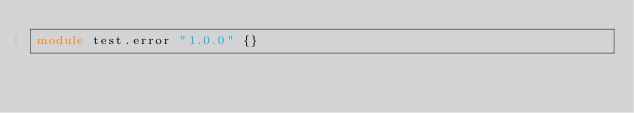Convert code to text. <code><loc_0><loc_0><loc_500><loc_500><_Ceylon_>module test.error "1.0.0" {}
</code> 